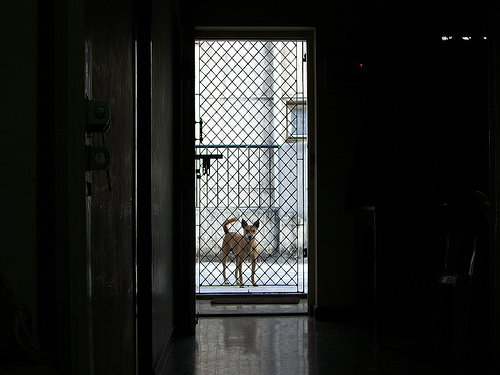<image>What is in front of the bike? There is no bike in the image. However, a dog could be in front of it. What is in front of the bike? I don't know what is in front of the bike. It can be seen a dog. 